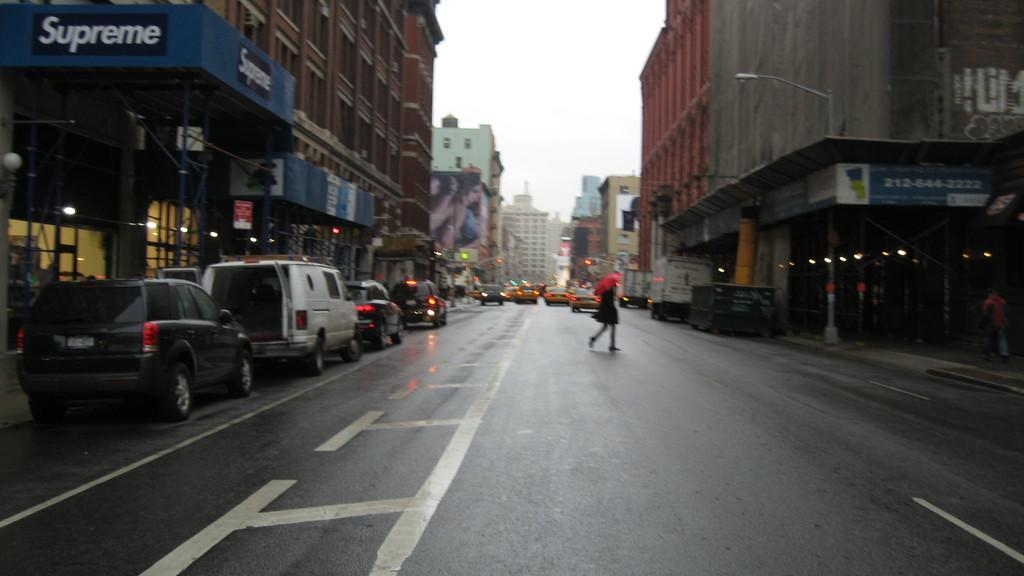What are the people in the image doing? There are persons walking in the image. What else can be seen in the image besides people? There are cars, buildings, and boards with text in the image. What is the condition of the sky in the image? The sky is cloudy in the image. Can you see a pan in the middle of the image? There is no pan present in the image. Are there any deer visible in the image? There are no deer present in the image. 